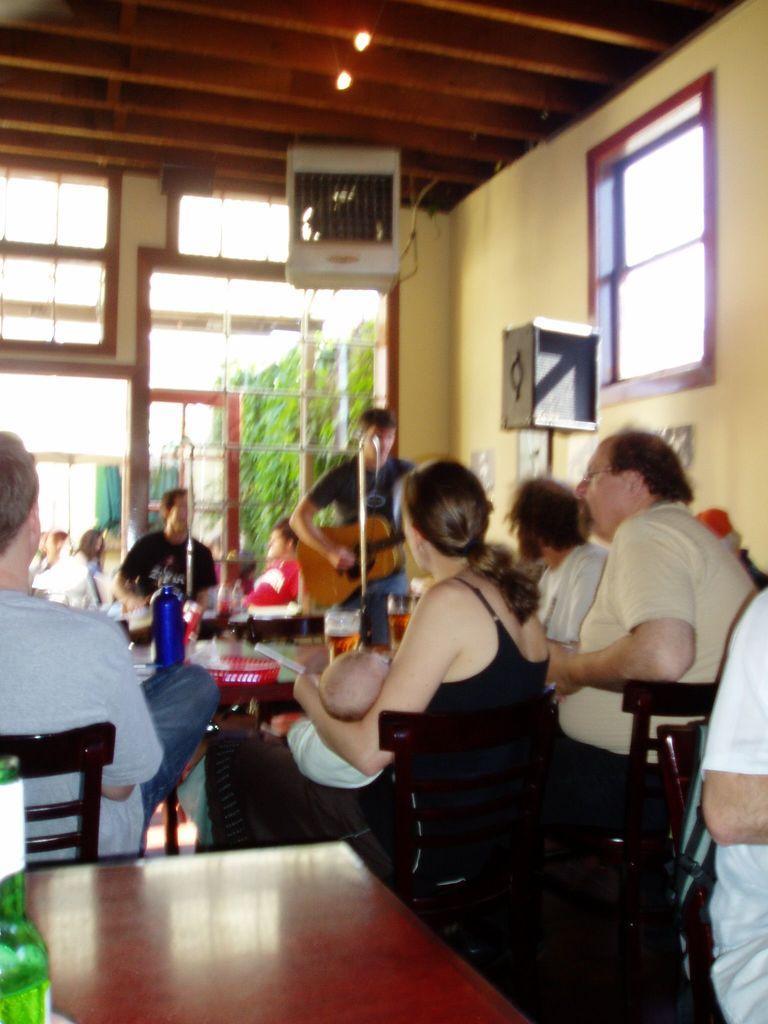In one or two sentences, can you explain what this image depicts? In this image we can see some persons, bottle, chairs, tables and other objects. In the background of the image there are glass windows, wall and other objects. Behind the glass windows there are trees and the sky. At the top of the image there is the ceiling with lights. At the bottom of the image there is a wooden surface and floor. On the left side of the image there is a bottle. On the right side of the image it looks like a chair and a person. 